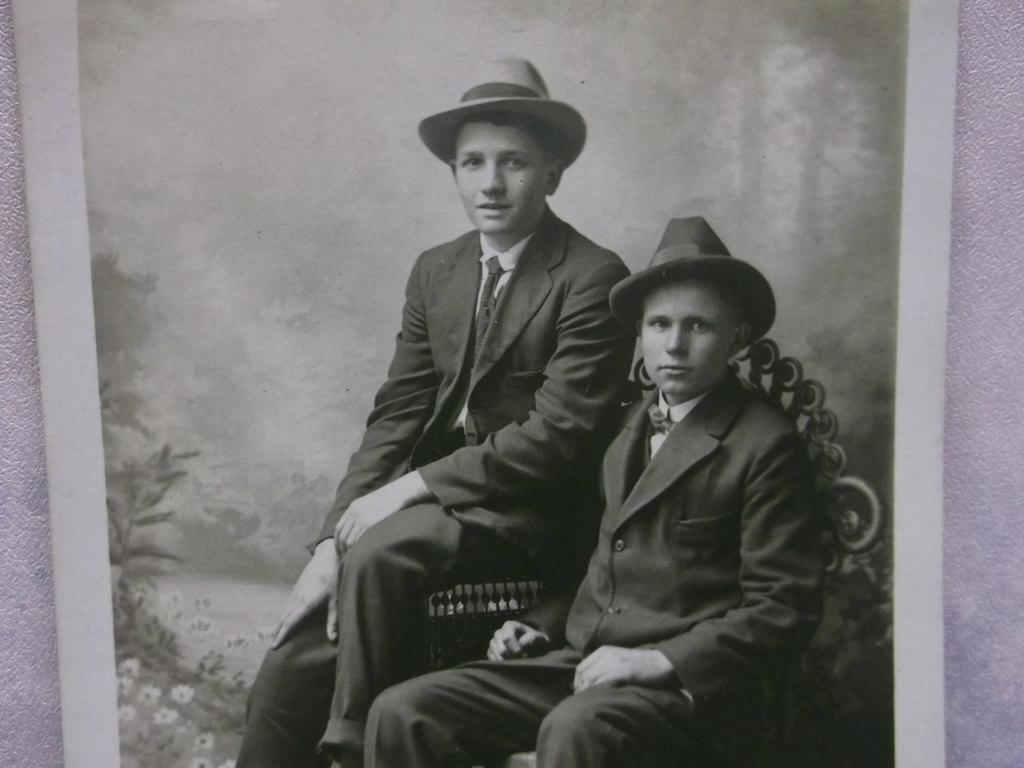What can be seen on the wall in the image? There is a photo frame on the wall in the image. What are the two persons in the image doing? The two persons are sitting in the image. What type of clothing are the persons wearing? The persons are wearing suits and caps. What type of truck is parked next to the persons in the image? There is no truck present in the image; it only features two persons sitting and a wall with a photo frame. How many secretaries are visible in the image? There are no secretaries present in the image. 